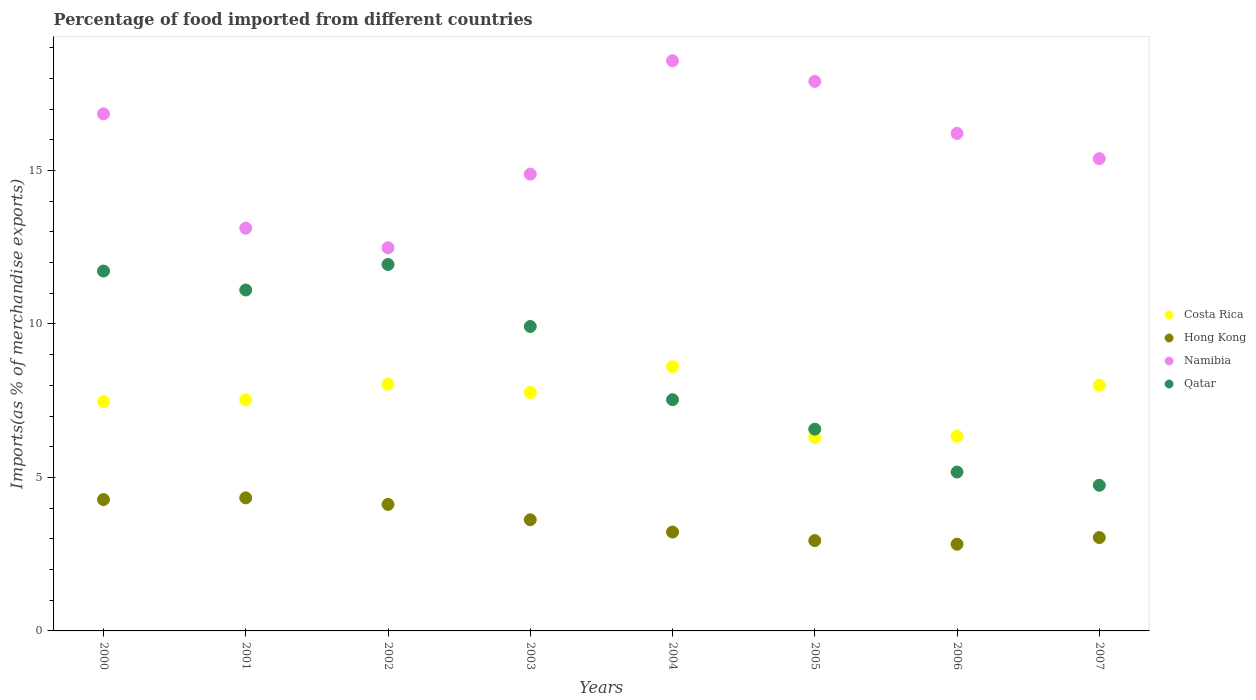How many different coloured dotlines are there?
Your response must be concise. 4. What is the percentage of imports to different countries in Costa Rica in 2004?
Provide a succinct answer. 8.61. Across all years, what is the maximum percentage of imports to different countries in Namibia?
Offer a very short reply. 18.57. Across all years, what is the minimum percentage of imports to different countries in Hong Kong?
Offer a terse response. 2.82. What is the total percentage of imports to different countries in Namibia in the graph?
Make the answer very short. 125.39. What is the difference between the percentage of imports to different countries in Namibia in 2001 and that in 2007?
Provide a short and direct response. -2.26. What is the difference between the percentage of imports to different countries in Hong Kong in 2003 and the percentage of imports to different countries in Qatar in 2005?
Make the answer very short. -2.95. What is the average percentage of imports to different countries in Qatar per year?
Your response must be concise. 8.59. In the year 2000, what is the difference between the percentage of imports to different countries in Hong Kong and percentage of imports to different countries in Costa Rica?
Your response must be concise. -3.19. In how many years, is the percentage of imports to different countries in Costa Rica greater than 12 %?
Offer a terse response. 0. What is the ratio of the percentage of imports to different countries in Namibia in 2005 to that in 2006?
Offer a terse response. 1.1. Is the percentage of imports to different countries in Qatar in 2002 less than that in 2006?
Give a very brief answer. No. What is the difference between the highest and the second highest percentage of imports to different countries in Costa Rica?
Offer a very short reply. 0.57. What is the difference between the highest and the lowest percentage of imports to different countries in Qatar?
Your answer should be very brief. 7.19. In how many years, is the percentage of imports to different countries in Costa Rica greater than the average percentage of imports to different countries in Costa Rica taken over all years?
Give a very brief answer. 5. Is the sum of the percentage of imports to different countries in Costa Rica in 2001 and 2002 greater than the maximum percentage of imports to different countries in Qatar across all years?
Your response must be concise. Yes. Is it the case that in every year, the sum of the percentage of imports to different countries in Qatar and percentage of imports to different countries in Namibia  is greater than the percentage of imports to different countries in Hong Kong?
Offer a terse response. Yes. Does the percentage of imports to different countries in Costa Rica monotonically increase over the years?
Your answer should be very brief. No. Is the percentage of imports to different countries in Costa Rica strictly less than the percentage of imports to different countries in Namibia over the years?
Offer a terse response. Yes. How many dotlines are there?
Provide a succinct answer. 4. How many years are there in the graph?
Keep it short and to the point. 8. What is the difference between two consecutive major ticks on the Y-axis?
Your answer should be very brief. 5. Does the graph contain grids?
Keep it short and to the point. No. Where does the legend appear in the graph?
Your response must be concise. Center right. What is the title of the graph?
Provide a succinct answer. Percentage of food imported from different countries. What is the label or title of the Y-axis?
Your answer should be very brief. Imports(as % of merchandise exports). What is the Imports(as % of merchandise exports) in Costa Rica in 2000?
Your answer should be very brief. 7.47. What is the Imports(as % of merchandise exports) of Hong Kong in 2000?
Give a very brief answer. 4.28. What is the Imports(as % of merchandise exports) in Namibia in 2000?
Keep it short and to the point. 16.84. What is the Imports(as % of merchandise exports) of Qatar in 2000?
Your answer should be compact. 11.72. What is the Imports(as % of merchandise exports) of Costa Rica in 2001?
Offer a very short reply. 7.53. What is the Imports(as % of merchandise exports) in Hong Kong in 2001?
Offer a terse response. 4.33. What is the Imports(as % of merchandise exports) of Namibia in 2001?
Ensure brevity in your answer.  13.12. What is the Imports(as % of merchandise exports) of Qatar in 2001?
Offer a very short reply. 11.11. What is the Imports(as % of merchandise exports) in Costa Rica in 2002?
Your answer should be compact. 8.04. What is the Imports(as % of merchandise exports) in Hong Kong in 2002?
Keep it short and to the point. 4.12. What is the Imports(as % of merchandise exports) of Namibia in 2002?
Keep it short and to the point. 12.48. What is the Imports(as % of merchandise exports) of Qatar in 2002?
Ensure brevity in your answer.  11.94. What is the Imports(as % of merchandise exports) in Costa Rica in 2003?
Your answer should be compact. 7.77. What is the Imports(as % of merchandise exports) of Hong Kong in 2003?
Give a very brief answer. 3.62. What is the Imports(as % of merchandise exports) of Namibia in 2003?
Your response must be concise. 14.88. What is the Imports(as % of merchandise exports) in Qatar in 2003?
Make the answer very short. 9.92. What is the Imports(as % of merchandise exports) of Costa Rica in 2004?
Provide a short and direct response. 8.61. What is the Imports(as % of merchandise exports) in Hong Kong in 2004?
Provide a short and direct response. 3.22. What is the Imports(as % of merchandise exports) in Namibia in 2004?
Provide a succinct answer. 18.57. What is the Imports(as % of merchandise exports) in Qatar in 2004?
Your response must be concise. 7.53. What is the Imports(as % of merchandise exports) in Costa Rica in 2005?
Your response must be concise. 6.3. What is the Imports(as % of merchandise exports) of Hong Kong in 2005?
Provide a succinct answer. 2.94. What is the Imports(as % of merchandise exports) of Namibia in 2005?
Offer a very short reply. 17.9. What is the Imports(as % of merchandise exports) of Qatar in 2005?
Keep it short and to the point. 6.57. What is the Imports(as % of merchandise exports) of Costa Rica in 2006?
Provide a succinct answer. 6.34. What is the Imports(as % of merchandise exports) of Hong Kong in 2006?
Give a very brief answer. 2.82. What is the Imports(as % of merchandise exports) in Namibia in 2006?
Ensure brevity in your answer.  16.21. What is the Imports(as % of merchandise exports) of Qatar in 2006?
Your answer should be compact. 5.18. What is the Imports(as % of merchandise exports) in Costa Rica in 2007?
Your response must be concise. 8.01. What is the Imports(as % of merchandise exports) in Hong Kong in 2007?
Ensure brevity in your answer.  3.04. What is the Imports(as % of merchandise exports) in Namibia in 2007?
Keep it short and to the point. 15.38. What is the Imports(as % of merchandise exports) in Qatar in 2007?
Ensure brevity in your answer.  4.74. Across all years, what is the maximum Imports(as % of merchandise exports) of Costa Rica?
Make the answer very short. 8.61. Across all years, what is the maximum Imports(as % of merchandise exports) in Hong Kong?
Offer a very short reply. 4.33. Across all years, what is the maximum Imports(as % of merchandise exports) of Namibia?
Your answer should be very brief. 18.57. Across all years, what is the maximum Imports(as % of merchandise exports) of Qatar?
Your answer should be compact. 11.94. Across all years, what is the minimum Imports(as % of merchandise exports) in Costa Rica?
Ensure brevity in your answer.  6.3. Across all years, what is the minimum Imports(as % of merchandise exports) in Hong Kong?
Your response must be concise. 2.82. Across all years, what is the minimum Imports(as % of merchandise exports) of Namibia?
Provide a succinct answer. 12.48. Across all years, what is the minimum Imports(as % of merchandise exports) of Qatar?
Provide a succinct answer. 4.74. What is the total Imports(as % of merchandise exports) in Costa Rica in the graph?
Offer a very short reply. 60.05. What is the total Imports(as % of merchandise exports) in Hong Kong in the graph?
Your answer should be very brief. 28.38. What is the total Imports(as % of merchandise exports) of Namibia in the graph?
Provide a succinct answer. 125.39. What is the total Imports(as % of merchandise exports) of Qatar in the graph?
Make the answer very short. 68.71. What is the difference between the Imports(as % of merchandise exports) in Costa Rica in 2000 and that in 2001?
Ensure brevity in your answer.  -0.06. What is the difference between the Imports(as % of merchandise exports) of Hong Kong in 2000 and that in 2001?
Keep it short and to the point. -0.06. What is the difference between the Imports(as % of merchandise exports) of Namibia in 2000 and that in 2001?
Provide a short and direct response. 3.72. What is the difference between the Imports(as % of merchandise exports) of Qatar in 2000 and that in 2001?
Offer a terse response. 0.62. What is the difference between the Imports(as % of merchandise exports) of Costa Rica in 2000 and that in 2002?
Provide a short and direct response. -0.57. What is the difference between the Imports(as % of merchandise exports) in Hong Kong in 2000 and that in 2002?
Your answer should be compact. 0.16. What is the difference between the Imports(as % of merchandise exports) in Namibia in 2000 and that in 2002?
Ensure brevity in your answer.  4.36. What is the difference between the Imports(as % of merchandise exports) of Qatar in 2000 and that in 2002?
Provide a succinct answer. -0.21. What is the difference between the Imports(as % of merchandise exports) of Costa Rica in 2000 and that in 2003?
Make the answer very short. -0.3. What is the difference between the Imports(as % of merchandise exports) of Hong Kong in 2000 and that in 2003?
Your answer should be very brief. 0.66. What is the difference between the Imports(as % of merchandise exports) of Namibia in 2000 and that in 2003?
Ensure brevity in your answer.  1.96. What is the difference between the Imports(as % of merchandise exports) in Qatar in 2000 and that in 2003?
Your answer should be compact. 1.81. What is the difference between the Imports(as % of merchandise exports) of Costa Rica in 2000 and that in 2004?
Give a very brief answer. -1.14. What is the difference between the Imports(as % of merchandise exports) of Hong Kong in 2000 and that in 2004?
Your answer should be very brief. 1.06. What is the difference between the Imports(as % of merchandise exports) of Namibia in 2000 and that in 2004?
Your answer should be very brief. -1.73. What is the difference between the Imports(as % of merchandise exports) of Qatar in 2000 and that in 2004?
Offer a very short reply. 4.19. What is the difference between the Imports(as % of merchandise exports) of Costa Rica in 2000 and that in 2005?
Offer a very short reply. 1.17. What is the difference between the Imports(as % of merchandise exports) in Hong Kong in 2000 and that in 2005?
Ensure brevity in your answer.  1.34. What is the difference between the Imports(as % of merchandise exports) of Namibia in 2000 and that in 2005?
Your answer should be very brief. -1.06. What is the difference between the Imports(as % of merchandise exports) in Qatar in 2000 and that in 2005?
Offer a very short reply. 5.15. What is the difference between the Imports(as % of merchandise exports) of Costa Rica in 2000 and that in 2006?
Your answer should be compact. 1.13. What is the difference between the Imports(as % of merchandise exports) of Hong Kong in 2000 and that in 2006?
Your answer should be very brief. 1.45. What is the difference between the Imports(as % of merchandise exports) in Namibia in 2000 and that in 2006?
Provide a succinct answer. 0.64. What is the difference between the Imports(as % of merchandise exports) of Qatar in 2000 and that in 2006?
Provide a short and direct response. 6.55. What is the difference between the Imports(as % of merchandise exports) of Costa Rica in 2000 and that in 2007?
Keep it short and to the point. -0.54. What is the difference between the Imports(as % of merchandise exports) of Hong Kong in 2000 and that in 2007?
Offer a very short reply. 1.24. What is the difference between the Imports(as % of merchandise exports) of Namibia in 2000 and that in 2007?
Your response must be concise. 1.46. What is the difference between the Imports(as % of merchandise exports) in Qatar in 2000 and that in 2007?
Make the answer very short. 6.98. What is the difference between the Imports(as % of merchandise exports) of Costa Rica in 2001 and that in 2002?
Your answer should be compact. -0.51. What is the difference between the Imports(as % of merchandise exports) of Hong Kong in 2001 and that in 2002?
Keep it short and to the point. 0.21. What is the difference between the Imports(as % of merchandise exports) in Namibia in 2001 and that in 2002?
Your answer should be very brief. 0.64. What is the difference between the Imports(as % of merchandise exports) in Qatar in 2001 and that in 2002?
Offer a very short reply. -0.83. What is the difference between the Imports(as % of merchandise exports) in Costa Rica in 2001 and that in 2003?
Your answer should be very brief. -0.24. What is the difference between the Imports(as % of merchandise exports) of Hong Kong in 2001 and that in 2003?
Offer a terse response. 0.71. What is the difference between the Imports(as % of merchandise exports) in Namibia in 2001 and that in 2003?
Your answer should be very brief. -1.76. What is the difference between the Imports(as % of merchandise exports) of Qatar in 2001 and that in 2003?
Your answer should be very brief. 1.19. What is the difference between the Imports(as % of merchandise exports) of Costa Rica in 2001 and that in 2004?
Ensure brevity in your answer.  -1.08. What is the difference between the Imports(as % of merchandise exports) of Hong Kong in 2001 and that in 2004?
Give a very brief answer. 1.11. What is the difference between the Imports(as % of merchandise exports) in Namibia in 2001 and that in 2004?
Your answer should be compact. -5.45. What is the difference between the Imports(as % of merchandise exports) in Qatar in 2001 and that in 2004?
Your response must be concise. 3.57. What is the difference between the Imports(as % of merchandise exports) of Costa Rica in 2001 and that in 2005?
Offer a terse response. 1.22. What is the difference between the Imports(as % of merchandise exports) in Hong Kong in 2001 and that in 2005?
Give a very brief answer. 1.39. What is the difference between the Imports(as % of merchandise exports) of Namibia in 2001 and that in 2005?
Your answer should be very brief. -4.78. What is the difference between the Imports(as % of merchandise exports) of Qatar in 2001 and that in 2005?
Your response must be concise. 4.53. What is the difference between the Imports(as % of merchandise exports) in Costa Rica in 2001 and that in 2006?
Make the answer very short. 1.18. What is the difference between the Imports(as % of merchandise exports) of Hong Kong in 2001 and that in 2006?
Provide a succinct answer. 1.51. What is the difference between the Imports(as % of merchandise exports) in Namibia in 2001 and that in 2006?
Your answer should be very brief. -3.09. What is the difference between the Imports(as % of merchandise exports) in Qatar in 2001 and that in 2006?
Offer a terse response. 5.93. What is the difference between the Imports(as % of merchandise exports) of Costa Rica in 2001 and that in 2007?
Provide a succinct answer. -0.48. What is the difference between the Imports(as % of merchandise exports) of Hong Kong in 2001 and that in 2007?
Offer a terse response. 1.29. What is the difference between the Imports(as % of merchandise exports) of Namibia in 2001 and that in 2007?
Your answer should be very brief. -2.26. What is the difference between the Imports(as % of merchandise exports) of Qatar in 2001 and that in 2007?
Offer a very short reply. 6.36. What is the difference between the Imports(as % of merchandise exports) in Costa Rica in 2002 and that in 2003?
Your answer should be compact. 0.27. What is the difference between the Imports(as % of merchandise exports) in Hong Kong in 2002 and that in 2003?
Your answer should be compact. 0.5. What is the difference between the Imports(as % of merchandise exports) of Namibia in 2002 and that in 2003?
Keep it short and to the point. -2.4. What is the difference between the Imports(as % of merchandise exports) of Qatar in 2002 and that in 2003?
Ensure brevity in your answer.  2.02. What is the difference between the Imports(as % of merchandise exports) in Costa Rica in 2002 and that in 2004?
Make the answer very short. -0.57. What is the difference between the Imports(as % of merchandise exports) of Hong Kong in 2002 and that in 2004?
Your answer should be very brief. 0.9. What is the difference between the Imports(as % of merchandise exports) in Namibia in 2002 and that in 2004?
Give a very brief answer. -6.09. What is the difference between the Imports(as % of merchandise exports) of Qatar in 2002 and that in 2004?
Make the answer very short. 4.4. What is the difference between the Imports(as % of merchandise exports) of Costa Rica in 2002 and that in 2005?
Offer a very short reply. 1.74. What is the difference between the Imports(as % of merchandise exports) of Hong Kong in 2002 and that in 2005?
Your answer should be compact. 1.18. What is the difference between the Imports(as % of merchandise exports) in Namibia in 2002 and that in 2005?
Keep it short and to the point. -5.42. What is the difference between the Imports(as % of merchandise exports) in Qatar in 2002 and that in 2005?
Make the answer very short. 5.36. What is the difference between the Imports(as % of merchandise exports) in Costa Rica in 2002 and that in 2006?
Offer a terse response. 1.7. What is the difference between the Imports(as % of merchandise exports) of Hong Kong in 2002 and that in 2006?
Make the answer very short. 1.3. What is the difference between the Imports(as % of merchandise exports) in Namibia in 2002 and that in 2006?
Offer a terse response. -3.72. What is the difference between the Imports(as % of merchandise exports) of Qatar in 2002 and that in 2006?
Give a very brief answer. 6.76. What is the difference between the Imports(as % of merchandise exports) of Costa Rica in 2002 and that in 2007?
Your answer should be compact. 0.03. What is the difference between the Imports(as % of merchandise exports) in Hong Kong in 2002 and that in 2007?
Provide a succinct answer. 1.08. What is the difference between the Imports(as % of merchandise exports) of Namibia in 2002 and that in 2007?
Make the answer very short. -2.9. What is the difference between the Imports(as % of merchandise exports) in Qatar in 2002 and that in 2007?
Offer a very short reply. 7.19. What is the difference between the Imports(as % of merchandise exports) in Costa Rica in 2003 and that in 2004?
Provide a short and direct response. -0.84. What is the difference between the Imports(as % of merchandise exports) of Hong Kong in 2003 and that in 2004?
Provide a short and direct response. 0.4. What is the difference between the Imports(as % of merchandise exports) in Namibia in 2003 and that in 2004?
Make the answer very short. -3.69. What is the difference between the Imports(as % of merchandise exports) of Qatar in 2003 and that in 2004?
Make the answer very short. 2.39. What is the difference between the Imports(as % of merchandise exports) of Costa Rica in 2003 and that in 2005?
Give a very brief answer. 1.46. What is the difference between the Imports(as % of merchandise exports) of Hong Kong in 2003 and that in 2005?
Offer a very short reply. 0.68. What is the difference between the Imports(as % of merchandise exports) of Namibia in 2003 and that in 2005?
Provide a succinct answer. -3.02. What is the difference between the Imports(as % of merchandise exports) of Qatar in 2003 and that in 2005?
Your response must be concise. 3.34. What is the difference between the Imports(as % of merchandise exports) in Costa Rica in 2003 and that in 2006?
Your response must be concise. 1.42. What is the difference between the Imports(as % of merchandise exports) in Hong Kong in 2003 and that in 2006?
Your answer should be compact. 0.8. What is the difference between the Imports(as % of merchandise exports) of Namibia in 2003 and that in 2006?
Make the answer very short. -1.33. What is the difference between the Imports(as % of merchandise exports) in Qatar in 2003 and that in 2006?
Provide a short and direct response. 4.74. What is the difference between the Imports(as % of merchandise exports) of Costa Rica in 2003 and that in 2007?
Ensure brevity in your answer.  -0.24. What is the difference between the Imports(as % of merchandise exports) of Hong Kong in 2003 and that in 2007?
Provide a succinct answer. 0.58. What is the difference between the Imports(as % of merchandise exports) of Namibia in 2003 and that in 2007?
Your response must be concise. -0.5. What is the difference between the Imports(as % of merchandise exports) of Qatar in 2003 and that in 2007?
Give a very brief answer. 5.17. What is the difference between the Imports(as % of merchandise exports) in Costa Rica in 2004 and that in 2005?
Your answer should be very brief. 2.31. What is the difference between the Imports(as % of merchandise exports) of Hong Kong in 2004 and that in 2005?
Ensure brevity in your answer.  0.28. What is the difference between the Imports(as % of merchandise exports) in Namibia in 2004 and that in 2005?
Provide a succinct answer. 0.67. What is the difference between the Imports(as % of merchandise exports) in Qatar in 2004 and that in 2005?
Offer a very short reply. 0.96. What is the difference between the Imports(as % of merchandise exports) in Costa Rica in 2004 and that in 2006?
Provide a short and direct response. 2.27. What is the difference between the Imports(as % of merchandise exports) of Hong Kong in 2004 and that in 2006?
Make the answer very short. 0.4. What is the difference between the Imports(as % of merchandise exports) in Namibia in 2004 and that in 2006?
Your response must be concise. 2.37. What is the difference between the Imports(as % of merchandise exports) of Qatar in 2004 and that in 2006?
Your response must be concise. 2.36. What is the difference between the Imports(as % of merchandise exports) in Costa Rica in 2004 and that in 2007?
Your answer should be compact. 0.6. What is the difference between the Imports(as % of merchandise exports) of Hong Kong in 2004 and that in 2007?
Give a very brief answer. 0.18. What is the difference between the Imports(as % of merchandise exports) of Namibia in 2004 and that in 2007?
Give a very brief answer. 3.19. What is the difference between the Imports(as % of merchandise exports) of Qatar in 2004 and that in 2007?
Your answer should be very brief. 2.79. What is the difference between the Imports(as % of merchandise exports) in Costa Rica in 2005 and that in 2006?
Your answer should be very brief. -0.04. What is the difference between the Imports(as % of merchandise exports) in Hong Kong in 2005 and that in 2006?
Ensure brevity in your answer.  0.12. What is the difference between the Imports(as % of merchandise exports) in Namibia in 2005 and that in 2006?
Offer a terse response. 1.69. What is the difference between the Imports(as % of merchandise exports) in Qatar in 2005 and that in 2006?
Give a very brief answer. 1.4. What is the difference between the Imports(as % of merchandise exports) of Costa Rica in 2005 and that in 2007?
Offer a terse response. -1.71. What is the difference between the Imports(as % of merchandise exports) in Hong Kong in 2005 and that in 2007?
Provide a succinct answer. -0.1. What is the difference between the Imports(as % of merchandise exports) in Namibia in 2005 and that in 2007?
Offer a very short reply. 2.52. What is the difference between the Imports(as % of merchandise exports) in Qatar in 2005 and that in 2007?
Offer a very short reply. 1.83. What is the difference between the Imports(as % of merchandise exports) in Costa Rica in 2006 and that in 2007?
Your answer should be very brief. -1.67. What is the difference between the Imports(as % of merchandise exports) of Hong Kong in 2006 and that in 2007?
Keep it short and to the point. -0.22. What is the difference between the Imports(as % of merchandise exports) of Namibia in 2006 and that in 2007?
Give a very brief answer. 0.82. What is the difference between the Imports(as % of merchandise exports) in Qatar in 2006 and that in 2007?
Keep it short and to the point. 0.43. What is the difference between the Imports(as % of merchandise exports) of Costa Rica in 2000 and the Imports(as % of merchandise exports) of Hong Kong in 2001?
Your answer should be compact. 3.13. What is the difference between the Imports(as % of merchandise exports) in Costa Rica in 2000 and the Imports(as % of merchandise exports) in Namibia in 2001?
Offer a very short reply. -5.65. What is the difference between the Imports(as % of merchandise exports) of Costa Rica in 2000 and the Imports(as % of merchandise exports) of Qatar in 2001?
Offer a terse response. -3.64. What is the difference between the Imports(as % of merchandise exports) of Hong Kong in 2000 and the Imports(as % of merchandise exports) of Namibia in 2001?
Provide a succinct answer. -8.84. What is the difference between the Imports(as % of merchandise exports) in Hong Kong in 2000 and the Imports(as % of merchandise exports) in Qatar in 2001?
Make the answer very short. -6.83. What is the difference between the Imports(as % of merchandise exports) of Namibia in 2000 and the Imports(as % of merchandise exports) of Qatar in 2001?
Keep it short and to the point. 5.74. What is the difference between the Imports(as % of merchandise exports) of Costa Rica in 2000 and the Imports(as % of merchandise exports) of Hong Kong in 2002?
Make the answer very short. 3.35. What is the difference between the Imports(as % of merchandise exports) in Costa Rica in 2000 and the Imports(as % of merchandise exports) in Namibia in 2002?
Provide a succinct answer. -5.01. What is the difference between the Imports(as % of merchandise exports) of Costa Rica in 2000 and the Imports(as % of merchandise exports) of Qatar in 2002?
Your answer should be compact. -4.47. What is the difference between the Imports(as % of merchandise exports) of Hong Kong in 2000 and the Imports(as % of merchandise exports) of Namibia in 2002?
Offer a very short reply. -8.2. What is the difference between the Imports(as % of merchandise exports) in Hong Kong in 2000 and the Imports(as % of merchandise exports) in Qatar in 2002?
Make the answer very short. -7.66. What is the difference between the Imports(as % of merchandise exports) of Namibia in 2000 and the Imports(as % of merchandise exports) of Qatar in 2002?
Ensure brevity in your answer.  4.91. What is the difference between the Imports(as % of merchandise exports) of Costa Rica in 2000 and the Imports(as % of merchandise exports) of Hong Kong in 2003?
Provide a succinct answer. 3.85. What is the difference between the Imports(as % of merchandise exports) in Costa Rica in 2000 and the Imports(as % of merchandise exports) in Namibia in 2003?
Give a very brief answer. -7.41. What is the difference between the Imports(as % of merchandise exports) in Costa Rica in 2000 and the Imports(as % of merchandise exports) in Qatar in 2003?
Your response must be concise. -2.45. What is the difference between the Imports(as % of merchandise exports) in Hong Kong in 2000 and the Imports(as % of merchandise exports) in Namibia in 2003?
Your answer should be very brief. -10.6. What is the difference between the Imports(as % of merchandise exports) of Hong Kong in 2000 and the Imports(as % of merchandise exports) of Qatar in 2003?
Provide a short and direct response. -5.64. What is the difference between the Imports(as % of merchandise exports) of Namibia in 2000 and the Imports(as % of merchandise exports) of Qatar in 2003?
Offer a very short reply. 6.93. What is the difference between the Imports(as % of merchandise exports) in Costa Rica in 2000 and the Imports(as % of merchandise exports) in Hong Kong in 2004?
Offer a terse response. 4.25. What is the difference between the Imports(as % of merchandise exports) of Costa Rica in 2000 and the Imports(as % of merchandise exports) of Namibia in 2004?
Give a very brief answer. -11.11. What is the difference between the Imports(as % of merchandise exports) in Costa Rica in 2000 and the Imports(as % of merchandise exports) in Qatar in 2004?
Your answer should be compact. -0.06. What is the difference between the Imports(as % of merchandise exports) of Hong Kong in 2000 and the Imports(as % of merchandise exports) of Namibia in 2004?
Offer a very short reply. -14.29. What is the difference between the Imports(as % of merchandise exports) in Hong Kong in 2000 and the Imports(as % of merchandise exports) in Qatar in 2004?
Offer a very short reply. -3.25. What is the difference between the Imports(as % of merchandise exports) in Namibia in 2000 and the Imports(as % of merchandise exports) in Qatar in 2004?
Your answer should be compact. 9.31. What is the difference between the Imports(as % of merchandise exports) of Costa Rica in 2000 and the Imports(as % of merchandise exports) of Hong Kong in 2005?
Offer a very short reply. 4.53. What is the difference between the Imports(as % of merchandise exports) of Costa Rica in 2000 and the Imports(as % of merchandise exports) of Namibia in 2005?
Offer a very short reply. -10.43. What is the difference between the Imports(as % of merchandise exports) of Costa Rica in 2000 and the Imports(as % of merchandise exports) of Qatar in 2005?
Your answer should be compact. 0.9. What is the difference between the Imports(as % of merchandise exports) of Hong Kong in 2000 and the Imports(as % of merchandise exports) of Namibia in 2005?
Give a very brief answer. -13.62. What is the difference between the Imports(as % of merchandise exports) of Hong Kong in 2000 and the Imports(as % of merchandise exports) of Qatar in 2005?
Give a very brief answer. -2.29. What is the difference between the Imports(as % of merchandise exports) in Namibia in 2000 and the Imports(as % of merchandise exports) in Qatar in 2005?
Provide a short and direct response. 10.27. What is the difference between the Imports(as % of merchandise exports) in Costa Rica in 2000 and the Imports(as % of merchandise exports) in Hong Kong in 2006?
Provide a short and direct response. 4.64. What is the difference between the Imports(as % of merchandise exports) in Costa Rica in 2000 and the Imports(as % of merchandise exports) in Namibia in 2006?
Provide a succinct answer. -8.74. What is the difference between the Imports(as % of merchandise exports) of Costa Rica in 2000 and the Imports(as % of merchandise exports) of Qatar in 2006?
Keep it short and to the point. 2.29. What is the difference between the Imports(as % of merchandise exports) in Hong Kong in 2000 and the Imports(as % of merchandise exports) in Namibia in 2006?
Provide a succinct answer. -11.93. What is the difference between the Imports(as % of merchandise exports) in Hong Kong in 2000 and the Imports(as % of merchandise exports) in Qatar in 2006?
Offer a terse response. -0.9. What is the difference between the Imports(as % of merchandise exports) in Namibia in 2000 and the Imports(as % of merchandise exports) in Qatar in 2006?
Your answer should be compact. 11.67. What is the difference between the Imports(as % of merchandise exports) in Costa Rica in 2000 and the Imports(as % of merchandise exports) in Hong Kong in 2007?
Offer a terse response. 4.43. What is the difference between the Imports(as % of merchandise exports) of Costa Rica in 2000 and the Imports(as % of merchandise exports) of Namibia in 2007?
Offer a very short reply. -7.91. What is the difference between the Imports(as % of merchandise exports) in Costa Rica in 2000 and the Imports(as % of merchandise exports) in Qatar in 2007?
Keep it short and to the point. 2.72. What is the difference between the Imports(as % of merchandise exports) in Hong Kong in 2000 and the Imports(as % of merchandise exports) in Namibia in 2007?
Provide a short and direct response. -11.1. What is the difference between the Imports(as % of merchandise exports) of Hong Kong in 2000 and the Imports(as % of merchandise exports) of Qatar in 2007?
Keep it short and to the point. -0.47. What is the difference between the Imports(as % of merchandise exports) in Namibia in 2000 and the Imports(as % of merchandise exports) in Qatar in 2007?
Give a very brief answer. 12.1. What is the difference between the Imports(as % of merchandise exports) of Costa Rica in 2001 and the Imports(as % of merchandise exports) of Hong Kong in 2002?
Give a very brief answer. 3.4. What is the difference between the Imports(as % of merchandise exports) in Costa Rica in 2001 and the Imports(as % of merchandise exports) in Namibia in 2002?
Provide a short and direct response. -4.96. What is the difference between the Imports(as % of merchandise exports) in Costa Rica in 2001 and the Imports(as % of merchandise exports) in Qatar in 2002?
Your response must be concise. -4.41. What is the difference between the Imports(as % of merchandise exports) in Hong Kong in 2001 and the Imports(as % of merchandise exports) in Namibia in 2002?
Your answer should be very brief. -8.15. What is the difference between the Imports(as % of merchandise exports) in Hong Kong in 2001 and the Imports(as % of merchandise exports) in Qatar in 2002?
Ensure brevity in your answer.  -7.6. What is the difference between the Imports(as % of merchandise exports) in Namibia in 2001 and the Imports(as % of merchandise exports) in Qatar in 2002?
Offer a very short reply. 1.18. What is the difference between the Imports(as % of merchandise exports) in Costa Rica in 2001 and the Imports(as % of merchandise exports) in Hong Kong in 2003?
Provide a succinct answer. 3.9. What is the difference between the Imports(as % of merchandise exports) in Costa Rica in 2001 and the Imports(as % of merchandise exports) in Namibia in 2003?
Make the answer very short. -7.36. What is the difference between the Imports(as % of merchandise exports) in Costa Rica in 2001 and the Imports(as % of merchandise exports) in Qatar in 2003?
Provide a succinct answer. -2.39. What is the difference between the Imports(as % of merchandise exports) of Hong Kong in 2001 and the Imports(as % of merchandise exports) of Namibia in 2003?
Your answer should be very brief. -10.55. What is the difference between the Imports(as % of merchandise exports) in Hong Kong in 2001 and the Imports(as % of merchandise exports) in Qatar in 2003?
Your answer should be compact. -5.58. What is the difference between the Imports(as % of merchandise exports) of Namibia in 2001 and the Imports(as % of merchandise exports) of Qatar in 2003?
Your answer should be very brief. 3.2. What is the difference between the Imports(as % of merchandise exports) in Costa Rica in 2001 and the Imports(as % of merchandise exports) in Hong Kong in 2004?
Give a very brief answer. 4.3. What is the difference between the Imports(as % of merchandise exports) of Costa Rica in 2001 and the Imports(as % of merchandise exports) of Namibia in 2004?
Make the answer very short. -11.05. What is the difference between the Imports(as % of merchandise exports) of Costa Rica in 2001 and the Imports(as % of merchandise exports) of Qatar in 2004?
Ensure brevity in your answer.  -0.01. What is the difference between the Imports(as % of merchandise exports) of Hong Kong in 2001 and the Imports(as % of merchandise exports) of Namibia in 2004?
Keep it short and to the point. -14.24. What is the difference between the Imports(as % of merchandise exports) in Hong Kong in 2001 and the Imports(as % of merchandise exports) in Qatar in 2004?
Keep it short and to the point. -3.2. What is the difference between the Imports(as % of merchandise exports) of Namibia in 2001 and the Imports(as % of merchandise exports) of Qatar in 2004?
Make the answer very short. 5.59. What is the difference between the Imports(as % of merchandise exports) of Costa Rica in 2001 and the Imports(as % of merchandise exports) of Hong Kong in 2005?
Ensure brevity in your answer.  4.58. What is the difference between the Imports(as % of merchandise exports) of Costa Rica in 2001 and the Imports(as % of merchandise exports) of Namibia in 2005?
Offer a terse response. -10.38. What is the difference between the Imports(as % of merchandise exports) in Costa Rica in 2001 and the Imports(as % of merchandise exports) in Qatar in 2005?
Offer a terse response. 0.95. What is the difference between the Imports(as % of merchandise exports) in Hong Kong in 2001 and the Imports(as % of merchandise exports) in Namibia in 2005?
Offer a very short reply. -13.57. What is the difference between the Imports(as % of merchandise exports) of Hong Kong in 2001 and the Imports(as % of merchandise exports) of Qatar in 2005?
Provide a succinct answer. -2.24. What is the difference between the Imports(as % of merchandise exports) in Namibia in 2001 and the Imports(as % of merchandise exports) in Qatar in 2005?
Offer a terse response. 6.55. What is the difference between the Imports(as % of merchandise exports) of Costa Rica in 2001 and the Imports(as % of merchandise exports) of Hong Kong in 2006?
Offer a terse response. 4.7. What is the difference between the Imports(as % of merchandise exports) of Costa Rica in 2001 and the Imports(as % of merchandise exports) of Namibia in 2006?
Your answer should be very brief. -8.68. What is the difference between the Imports(as % of merchandise exports) of Costa Rica in 2001 and the Imports(as % of merchandise exports) of Qatar in 2006?
Your answer should be compact. 2.35. What is the difference between the Imports(as % of merchandise exports) in Hong Kong in 2001 and the Imports(as % of merchandise exports) in Namibia in 2006?
Provide a short and direct response. -11.87. What is the difference between the Imports(as % of merchandise exports) in Hong Kong in 2001 and the Imports(as % of merchandise exports) in Qatar in 2006?
Give a very brief answer. -0.84. What is the difference between the Imports(as % of merchandise exports) of Namibia in 2001 and the Imports(as % of merchandise exports) of Qatar in 2006?
Give a very brief answer. 7.94. What is the difference between the Imports(as % of merchandise exports) of Costa Rica in 2001 and the Imports(as % of merchandise exports) of Hong Kong in 2007?
Ensure brevity in your answer.  4.48. What is the difference between the Imports(as % of merchandise exports) of Costa Rica in 2001 and the Imports(as % of merchandise exports) of Namibia in 2007?
Make the answer very short. -7.86. What is the difference between the Imports(as % of merchandise exports) in Costa Rica in 2001 and the Imports(as % of merchandise exports) in Qatar in 2007?
Your answer should be very brief. 2.78. What is the difference between the Imports(as % of merchandise exports) of Hong Kong in 2001 and the Imports(as % of merchandise exports) of Namibia in 2007?
Provide a succinct answer. -11.05. What is the difference between the Imports(as % of merchandise exports) in Hong Kong in 2001 and the Imports(as % of merchandise exports) in Qatar in 2007?
Make the answer very short. -0.41. What is the difference between the Imports(as % of merchandise exports) of Namibia in 2001 and the Imports(as % of merchandise exports) of Qatar in 2007?
Make the answer very short. 8.38. What is the difference between the Imports(as % of merchandise exports) of Costa Rica in 2002 and the Imports(as % of merchandise exports) of Hong Kong in 2003?
Ensure brevity in your answer.  4.42. What is the difference between the Imports(as % of merchandise exports) in Costa Rica in 2002 and the Imports(as % of merchandise exports) in Namibia in 2003?
Ensure brevity in your answer.  -6.84. What is the difference between the Imports(as % of merchandise exports) in Costa Rica in 2002 and the Imports(as % of merchandise exports) in Qatar in 2003?
Offer a very short reply. -1.88. What is the difference between the Imports(as % of merchandise exports) of Hong Kong in 2002 and the Imports(as % of merchandise exports) of Namibia in 2003?
Offer a terse response. -10.76. What is the difference between the Imports(as % of merchandise exports) in Hong Kong in 2002 and the Imports(as % of merchandise exports) in Qatar in 2003?
Keep it short and to the point. -5.8. What is the difference between the Imports(as % of merchandise exports) of Namibia in 2002 and the Imports(as % of merchandise exports) of Qatar in 2003?
Provide a short and direct response. 2.56. What is the difference between the Imports(as % of merchandise exports) of Costa Rica in 2002 and the Imports(as % of merchandise exports) of Hong Kong in 2004?
Keep it short and to the point. 4.82. What is the difference between the Imports(as % of merchandise exports) of Costa Rica in 2002 and the Imports(as % of merchandise exports) of Namibia in 2004?
Make the answer very short. -10.53. What is the difference between the Imports(as % of merchandise exports) in Costa Rica in 2002 and the Imports(as % of merchandise exports) in Qatar in 2004?
Make the answer very short. 0.51. What is the difference between the Imports(as % of merchandise exports) in Hong Kong in 2002 and the Imports(as % of merchandise exports) in Namibia in 2004?
Your answer should be compact. -14.45. What is the difference between the Imports(as % of merchandise exports) in Hong Kong in 2002 and the Imports(as % of merchandise exports) in Qatar in 2004?
Make the answer very short. -3.41. What is the difference between the Imports(as % of merchandise exports) of Namibia in 2002 and the Imports(as % of merchandise exports) of Qatar in 2004?
Keep it short and to the point. 4.95. What is the difference between the Imports(as % of merchandise exports) of Costa Rica in 2002 and the Imports(as % of merchandise exports) of Hong Kong in 2005?
Offer a very short reply. 5.1. What is the difference between the Imports(as % of merchandise exports) in Costa Rica in 2002 and the Imports(as % of merchandise exports) in Namibia in 2005?
Keep it short and to the point. -9.86. What is the difference between the Imports(as % of merchandise exports) in Costa Rica in 2002 and the Imports(as % of merchandise exports) in Qatar in 2005?
Your answer should be very brief. 1.47. What is the difference between the Imports(as % of merchandise exports) in Hong Kong in 2002 and the Imports(as % of merchandise exports) in Namibia in 2005?
Keep it short and to the point. -13.78. What is the difference between the Imports(as % of merchandise exports) of Hong Kong in 2002 and the Imports(as % of merchandise exports) of Qatar in 2005?
Offer a very short reply. -2.45. What is the difference between the Imports(as % of merchandise exports) of Namibia in 2002 and the Imports(as % of merchandise exports) of Qatar in 2005?
Keep it short and to the point. 5.91. What is the difference between the Imports(as % of merchandise exports) in Costa Rica in 2002 and the Imports(as % of merchandise exports) in Hong Kong in 2006?
Your response must be concise. 5.21. What is the difference between the Imports(as % of merchandise exports) in Costa Rica in 2002 and the Imports(as % of merchandise exports) in Namibia in 2006?
Provide a succinct answer. -8.17. What is the difference between the Imports(as % of merchandise exports) of Costa Rica in 2002 and the Imports(as % of merchandise exports) of Qatar in 2006?
Make the answer very short. 2.86. What is the difference between the Imports(as % of merchandise exports) of Hong Kong in 2002 and the Imports(as % of merchandise exports) of Namibia in 2006?
Offer a very short reply. -12.09. What is the difference between the Imports(as % of merchandise exports) of Hong Kong in 2002 and the Imports(as % of merchandise exports) of Qatar in 2006?
Make the answer very short. -1.05. What is the difference between the Imports(as % of merchandise exports) of Namibia in 2002 and the Imports(as % of merchandise exports) of Qatar in 2006?
Make the answer very short. 7.31. What is the difference between the Imports(as % of merchandise exports) in Costa Rica in 2002 and the Imports(as % of merchandise exports) in Hong Kong in 2007?
Ensure brevity in your answer.  5. What is the difference between the Imports(as % of merchandise exports) in Costa Rica in 2002 and the Imports(as % of merchandise exports) in Namibia in 2007?
Your answer should be very brief. -7.34. What is the difference between the Imports(as % of merchandise exports) of Costa Rica in 2002 and the Imports(as % of merchandise exports) of Qatar in 2007?
Offer a terse response. 3.3. What is the difference between the Imports(as % of merchandise exports) in Hong Kong in 2002 and the Imports(as % of merchandise exports) in Namibia in 2007?
Provide a short and direct response. -11.26. What is the difference between the Imports(as % of merchandise exports) in Hong Kong in 2002 and the Imports(as % of merchandise exports) in Qatar in 2007?
Keep it short and to the point. -0.62. What is the difference between the Imports(as % of merchandise exports) of Namibia in 2002 and the Imports(as % of merchandise exports) of Qatar in 2007?
Provide a succinct answer. 7.74. What is the difference between the Imports(as % of merchandise exports) in Costa Rica in 2003 and the Imports(as % of merchandise exports) in Hong Kong in 2004?
Your answer should be very brief. 4.54. What is the difference between the Imports(as % of merchandise exports) in Costa Rica in 2003 and the Imports(as % of merchandise exports) in Namibia in 2004?
Provide a succinct answer. -10.81. What is the difference between the Imports(as % of merchandise exports) in Costa Rica in 2003 and the Imports(as % of merchandise exports) in Qatar in 2004?
Make the answer very short. 0.23. What is the difference between the Imports(as % of merchandise exports) of Hong Kong in 2003 and the Imports(as % of merchandise exports) of Namibia in 2004?
Make the answer very short. -14.95. What is the difference between the Imports(as % of merchandise exports) in Hong Kong in 2003 and the Imports(as % of merchandise exports) in Qatar in 2004?
Keep it short and to the point. -3.91. What is the difference between the Imports(as % of merchandise exports) in Namibia in 2003 and the Imports(as % of merchandise exports) in Qatar in 2004?
Your response must be concise. 7.35. What is the difference between the Imports(as % of merchandise exports) of Costa Rica in 2003 and the Imports(as % of merchandise exports) of Hong Kong in 2005?
Ensure brevity in your answer.  4.82. What is the difference between the Imports(as % of merchandise exports) of Costa Rica in 2003 and the Imports(as % of merchandise exports) of Namibia in 2005?
Make the answer very short. -10.14. What is the difference between the Imports(as % of merchandise exports) of Costa Rica in 2003 and the Imports(as % of merchandise exports) of Qatar in 2005?
Keep it short and to the point. 1.19. What is the difference between the Imports(as % of merchandise exports) in Hong Kong in 2003 and the Imports(as % of merchandise exports) in Namibia in 2005?
Ensure brevity in your answer.  -14.28. What is the difference between the Imports(as % of merchandise exports) of Hong Kong in 2003 and the Imports(as % of merchandise exports) of Qatar in 2005?
Your answer should be very brief. -2.95. What is the difference between the Imports(as % of merchandise exports) in Namibia in 2003 and the Imports(as % of merchandise exports) in Qatar in 2005?
Provide a short and direct response. 8.31. What is the difference between the Imports(as % of merchandise exports) in Costa Rica in 2003 and the Imports(as % of merchandise exports) in Hong Kong in 2006?
Offer a terse response. 4.94. What is the difference between the Imports(as % of merchandise exports) in Costa Rica in 2003 and the Imports(as % of merchandise exports) in Namibia in 2006?
Provide a short and direct response. -8.44. What is the difference between the Imports(as % of merchandise exports) in Costa Rica in 2003 and the Imports(as % of merchandise exports) in Qatar in 2006?
Offer a terse response. 2.59. What is the difference between the Imports(as % of merchandise exports) in Hong Kong in 2003 and the Imports(as % of merchandise exports) in Namibia in 2006?
Offer a very short reply. -12.59. What is the difference between the Imports(as % of merchandise exports) of Hong Kong in 2003 and the Imports(as % of merchandise exports) of Qatar in 2006?
Offer a very short reply. -1.55. What is the difference between the Imports(as % of merchandise exports) in Namibia in 2003 and the Imports(as % of merchandise exports) in Qatar in 2006?
Offer a terse response. 9.71. What is the difference between the Imports(as % of merchandise exports) of Costa Rica in 2003 and the Imports(as % of merchandise exports) of Hong Kong in 2007?
Your response must be concise. 4.72. What is the difference between the Imports(as % of merchandise exports) in Costa Rica in 2003 and the Imports(as % of merchandise exports) in Namibia in 2007?
Give a very brief answer. -7.62. What is the difference between the Imports(as % of merchandise exports) in Costa Rica in 2003 and the Imports(as % of merchandise exports) in Qatar in 2007?
Provide a succinct answer. 3.02. What is the difference between the Imports(as % of merchandise exports) in Hong Kong in 2003 and the Imports(as % of merchandise exports) in Namibia in 2007?
Offer a very short reply. -11.76. What is the difference between the Imports(as % of merchandise exports) of Hong Kong in 2003 and the Imports(as % of merchandise exports) of Qatar in 2007?
Make the answer very short. -1.12. What is the difference between the Imports(as % of merchandise exports) in Namibia in 2003 and the Imports(as % of merchandise exports) in Qatar in 2007?
Offer a very short reply. 10.14. What is the difference between the Imports(as % of merchandise exports) of Costa Rica in 2004 and the Imports(as % of merchandise exports) of Hong Kong in 2005?
Offer a terse response. 5.66. What is the difference between the Imports(as % of merchandise exports) of Costa Rica in 2004 and the Imports(as % of merchandise exports) of Namibia in 2005?
Offer a very short reply. -9.29. What is the difference between the Imports(as % of merchandise exports) of Costa Rica in 2004 and the Imports(as % of merchandise exports) of Qatar in 2005?
Your answer should be compact. 2.03. What is the difference between the Imports(as % of merchandise exports) in Hong Kong in 2004 and the Imports(as % of merchandise exports) in Namibia in 2005?
Provide a succinct answer. -14.68. What is the difference between the Imports(as % of merchandise exports) of Hong Kong in 2004 and the Imports(as % of merchandise exports) of Qatar in 2005?
Keep it short and to the point. -3.35. What is the difference between the Imports(as % of merchandise exports) of Namibia in 2004 and the Imports(as % of merchandise exports) of Qatar in 2005?
Give a very brief answer. 12. What is the difference between the Imports(as % of merchandise exports) in Costa Rica in 2004 and the Imports(as % of merchandise exports) in Hong Kong in 2006?
Offer a terse response. 5.78. What is the difference between the Imports(as % of merchandise exports) in Costa Rica in 2004 and the Imports(as % of merchandise exports) in Namibia in 2006?
Offer a very short reply. -7.6. What is the difference between the Imports(as % of merchandise exports) of Costa Rica in 2004 and the Imports(as % of merchandise exports) of Qatar in 2006?
Offer a terse response. 3.43. What is the difference between the Imports(as % of merchandise exports) of Hong Kong in 2004 and the Imports(as % of merchandise exports) of Namibia in 2006?
Make the answer very short. -12.98. What is the difference between the Imports(as % of merchandise exports) in Hong Kong in 2004 and the Imports(as % of merchandise exports) in Qatar in 2006?
Give a very brief answer. -1.95. What is the difference between the Imports(as % of merchandise exports) in Namibia in 2004 and the Imports(as % of merchandise exports) in Qatar in 2006?
Offer a terse response. 13.4. What is the difference between the Imports(as % of merchandise exports) of Costa Rica in 2004 and the Imports(as % of merchandise exports) of Hong Kong in 2007?
Keep it short and to the point. 5.57. What is the difference between the Imports(as % of merchandise exports) in Costa Rica in 2004 and the Imports(as % of merchandise exports) in Namibia in 2007?
Offer a very short reply. -6.78. What is the difference between the Imports(as % of merchandise exports) in Costa Rica in 2004 and the Imports(as % of merchandise exports) in Qatar in 2007?
Offer a terse response. 3.86. What is the difference between the Imports(as % of merchandise exports) in Hong Kong in 2004 and the Imports(as % of merchandise exports) in Namibia in 2007?
Your response must be concise. -12.16. What is the difference between the Imports(as % of merchandise exports) in Hong Kong in 2004 and the Imports(as % of merchandise exports) in Qatar in 2007?
Your answer should be very brief. -1.52. What is the difference between the Imports(as % of merchandise exports) of Namibia in 2004 and the Imports(as % of merchandise exports) of Qatar in 2007?
Your answer should be very brief. 13.83. What is the difference between the Imports(as % of merchandise exports) of Costa Rica in 2005 and the Imports(as % of merchandise exports) of Hong Kong in 2006?
Your answer should be compact. 3.48. What is the difference between the Imports(as % of merchandise exports) of Costa Rica in 2005 and the Imports(as % of merchandise exports) of Namibia in 2006?
Ensure brevity in your answer.  -9.91. What is the difference between the Imports(as % of merchandise exports) of Costa Rica in 2005 and the Imports(as % of merchandise exports) of Qatar in 2006?
Offer a very short reply. 1.13. What is the difference between the Imports(as % of merchandise exports) in Hong Kong in 2005 and the Imports(as % of merchandise exports) in Namibia in 2006?
Offer a terse response. -13.26. What is the difference between the Imports(as % of merchandise exports) of Hong Kong in 2005 and the Imports(as % of merchandise exports) of Qatar in 2006?
Keep it short and to the point. -2.23. What is the difference between the Imports(as % of merchandise exports) in Namibia in 2005 and the Imports(as % of merchandise exports) in Qatar in 2006?
Offer a very short reply. 12.73. What is the difference between the Imports(as % of merchandise exports) of Costa Rica in 2005 and the Imports(as % of merchandise exports) of Hong Kong in 2007?
Offer a very short reply. 3.26. What is the difference between the Imports(as % of merchandise exports) in Costa Rica in 2005 and the Imports(as % of merchandise exports) in Namibia in 2007?
Offer a terse response. -9.08. What is the difference between the Imports(as % of merchandise exports) of Costa Rica in 2005 and the Imports(as % of merchandise exports) of Qatar in 2007?
Keep it short and to the point. 1.56. What is the difference between the Imports(as % of merchandise exports) in Hong Kong in 2005 and the Imports(as % of merchandise exports) in Namibia in 2007?
Your answer should be compact. -12.44. What is the difference between the Imports(as % of merchandise exports) in Hong Kong in 2005 and the Imports(as % of merchandise exports) in Qatar in 2007?
Your answer should be very brief. -1.8. What is the difference between the Imports(as % of merchandise exports) of Namibia in 2005 and the Imports(as % of merchandise exports) of Qatar in 2007?
Keep it short and to the point. 13.16. What is the difference between the Imports(as % of merchandise exports) of Costa Rica in 2006 and the Imports(as % of merchandise exports) of Hong Kong in 2007?
Ensure brevity in your answer.  3.3. What is the difference between the Imports(as % of merchandise exports) in Costa Rica in 2006 and the Imports(as % of merchandise exports) in Namibia in 2007?
Your answer should be very brief. -9.04. What is the difference between the Imports(as % of merchandise exports) of Costa Rica in 2006 and the Imports(as % of merchandise exports) of Qatar in 2007?
Offer a terse response. 1.6. What is the difference between the Imports(as % of merchandise exports) in Hong Kong in 2006 and the Imports(as % of merchandise exports) in Namibia in 2007?
Your answer should be compact. -12.56. What is the difference between the Imports(as % of merchandise exports) of Hong Kong in 2006 and the Imports(as % of merchandise exports) of Qatar in 2007?
Offer a terse response. -1.92. What is the difference between the Imports(as % of merchandise exports) in Namibia in 2006 and the Imports(as % of merchandise exports) in Qatar in 2007?
Give a very brief answer. 11.46. What is the average Imports(as % of merchandise exports) in Costa Rica per year?
Your response must be concise. 7.51. What is the average Imports(as % of merchandise exports) of Hong Kong per year?
Offer a terse response. 3.55. What is the average Imports(as % of merchandise exports) of Namibia per year?
Offer a terse response. 15.67. What is the average Imports(as % of merchandise exports) in Qatar per year?
Your answer should be compact. 8.59. In the year 2000, what is the difference between the Imports(as % of merchandise exports) of Costa Rica and Imports(as % of merchandise exports) of Hong Kong?
Offer a terse response. 3.19. In the year 2000, what is the difference between the Imports(as % of merchandise exports) of Costa Rica and Imports(as % of merchandise exports) of Namibia?
Your answer should be compact. -9.37. In the year 2000, what is the difference between the Imports(as % of merchandise exports) in Costa Rica and Imports(as % of merchandise exports) in Qatar?
Your answer should be compact. -4.25. In the year 2000, what is the difference between the Imports(as % of merchandise exports) in Hong Kong and Imports(as % of merchandise exports) in Namibia?
Keep it short and to the point. -12.56. In the year 2000, what is the difference between the Imports(as % of merchandise exports) in Hong Kong and Imports(as % of merchandise exports) in Qatar?
Offer a very short reply. -7.44. In the year 2000, what is the difference between the Imports(as % of merchandise exports) in Namibia and Imports(as % of merchandise exports) in Qatar?
Your answer should be very brief. 5.12. In the year 2001, what is the difference between the Imports(as % of merchandise exports) of Costa Rica and Imports(as % of merchandise exports) of Hong Kong?
Make the answer very short. 3.19. In the year 2001, what is the difference between the Imports(as % of merchandise exports) of Costa Rica and Imports(as % of merchandise exports) of Namibia?
Provide a short and direct response. -5.59. In the year 2001, what is the difference between the Imports(as % of merchandise exports) of Costa Rica and Imports(as % of merchandise exports) of Qatar?
Offer a very short reply. -3.58. In the year 2001, what is the difference between the Imports(as % of merchandise exports) in Hong Kong and Imports(as % of merchandise exports) in Namibia?
Provide a short and direct response. -8.79. In the year 2001, what is the difference between the Imports(as % of merchandise exports) in Hong Kong and Imports(as % of merchandise exports) in Qatar?
Your response must be concise. -6.77. In the year 2001, what is the difference between the Imports(as % of merchandise exports) in Namibia and Imports(as % of merchandise exports) in Qatar?
Offer a very short reply. 2.01. In the year 2002, what is the difference between the Imports(as % of merchandise exports) of Costa Rica and Imports(as % of merchandise exports) of Hong Kong?
Provide a short and direct response. 3.92. In the year 2002, what is the difference between the Imports(as % of merchandise exports) in Costa Rica and Imports(as % of merchandise exports) in Namibia?
Provide a succinct answer. -4.44. In the year 2002, what is the difference between the Imports(as % of merchandise exports) in Costa Rica and Imports(as % of merchandise exports) in Qatar?
Keep it short and to the point. -3.9. In the year 2002, what is the difference between the Imports(as % of merchandise exports) of Hong Kong and Imports(as % of merchandise exports) of Namibia?
Your answer should be very brief. -8.36. In the year 2002, what is the difference between the Imports(as % of merchandise exports) of Hong Kong and Imports(as % of merchandise exports) of Qatar?
Your response must be concise. -7.82. In the year 2002, what is the difference between the Imports(as % of merchandise exports) in Namibia and Imports(as % of merchandise exports) in Qatar?
Your answer should be compact. 0.55. In the year 2003, what is the difference between the Imports(as % of merchandise exports) of Costa Rica and Imports(as % of merchandise exports) of Hong Kong?
Provide a short and direct response. 4.14. In the year 2003, what is the difference between the Imports(as % of merchandise exports) of Costa Rica and Imports(as % of merchandise exports) of Namibia?
Your answer should be very brief. -7.12. In the year 2003, what is the difference between the Imports(as % of merchandise exports) in Costa Rica and Imports(as % of merchandise exports) in Qatar?
Your answer should be compact. -2.15. In the year 2003, what is the difference between the Imports(as % of merchandise exports) in Hong Kong and Imports(as % of merchandise exports) in Namibia?
Your answer should be compact. -11.26. In the year 2003, what is the difference between the Imports(as % of merchandise exports) in Hong Kong and Imports(as % of merchandise exports) in Qatar?
Provide a succinct answer. -6.3. In the year 2003, what is the difference between the Imports(as % of merchandise exports) in Namibia and Imports(as % of merchandise exports) in Qatar?
Provide a succinct answer. 4.96. In the year 2004, what is the difference between the Imports(as % of merchandise exports) of Costa Rica and Imports(as % of merchandise exports) of Hong Kong?
Provide a succinct answer. 5.38. In the year 2004, what is the difference between the Imports(as % of merchandise exports) of Costa Rica and Imports(as % of merchandise exports) of Namibia?
Provide a short and direct response. -9.97. In the year 2004, what is the difference between the Imports(as % of merchandise exports) in Costa Rica and Imports(as % of merchandise exports) in Qatar?
Ensure brevity in your answer.  1.07. In the year 2004, what is the difference between the Imports(as % of merchandise exports) of Hong Kong and Imports(as % of merchandise exports) of Namibia?
Offer a terse response. -15.35. In the year 2004, what is the difference between the Imports(as % of merchandise exports) of Hong Kong and Imports(as % of merchandise exports) of Qatar?
Offer a terse response. -4.31. In the year 2004, what is the difference between the Imports(as % of merchandise exports) of Namibia and Imports(as % of merchandise exports) of Qatar?
Give a very brief answer. 11.04. In the year 2005, what is the difference between the Imports(as % of merchandise exports) of Costa Rica and Imports(as % of merchandise exports) of Hong Kong?
Your response must be concise. 3.36. In the year 2005, what is the difference between the Imports(as % of merchandise exports) of Costa Rica and Imports(as % of merchandise exports) of Namibia?
Offer a terse response. -11.6. In the year 2005, what is the difference between the Imports(as % of merchandise exports) of Costa Rica and Imports(as % of merchandise exports) of Qatar?
Your answer should be very brief. -0.27. In the year 2005, what is the difference between the Imports(as % of merchandise exports) in Hong Kong and Imports(as % of merchandise exports) in Namibia?
Provide a short and direct response. -14.96. In the year 2005, what is the difference between the Imports(as % of merchandise exports) of Hong Kong and Imports(as % of merchandise exports) of Qatar?
Provide a short and direct response. -3.63. In the year 2005, what is the difference between the Imports(as % of merchandise exports) in Namibia and Imports(as % of merchandise exports) in Qatar?
Your response must be concise. 11.33. In the year 2006, what is the difference between the Imports(as % of merchandise exports) of Costa Rica and Imports(as % of merchandise exports) of Hong Kong?
Provide a short and direct response. 3.52. In the year 2006, what is the difference between the Imports(as % of merchandise exports) in Costa Rica and Imports(as % of merchandise exports) in Namibia?
Keep it short and to the point. -9.87. In the year 2006, what is the difference between the Imports(as % of merchandise exports) in Costa Rica and Imports(as % of merchandise exports) in Qatar?
Provide a short and direct response. 1.17. In the year 2006, what is the difference between the Imports(as % of merchandise exports) in Hong Kong and Imports(as % of merchandise exports) in Namibia?
Offer a terse response. -13.38. In the year 2006, what is the difference between the Imports(as % of merchandise exports) in Hong Kong and Imports(as % of merchandise exports) in Qatar?
Give a very brief answer. -2.35. In the year 2006, what is the difference between the Imports(as % of merchandise exports) of Namibia and Imports(as % of merchandise exports) of Qatar?
Provide a succinct answer. 11.03. In the year 2007, what is the difference between the Imports(as % of merchandise exports) in Costa Rica and Imports(as % of merchandise exports) in Hong Kong?
Your response must be concise. 4.97. In the year 2007, what is the difference between the Imports(as % of merchandise exports) of Costa Rica and Imports(as % of merchandise exports) of Namibia?
Offer a very short reply. -7.38. In the year 2007, what is the difference between the Imports(as % of merchandise exports) of Costa Rica and Imports(as % of merchandise exports) of Qatar?
Provide a short and direct response. 3.26. In the year 2007, what is the difference between the Imports(as % of merchandise exports) in Hong Kong and Imports(as % of merchandise exports) in Namibia?
Give a very brief answer. -12.34. In the year 2007, what is the difference between the Imports(as % of merchandise exports) of Hong Kong and Imports(as % of merchandise exports) of Qatar?
Ensure brevity in your answer.  -1.7. In the year 2007, what is the difference between the Imports(as % of merchandise exports) in Namibia and Imports(as % of merchandise exports) in Qatar?
Keep it short and to the point. 10.64. What is the ratio of the Imports(as % of merchandise exports) in Hong Kong in 2000 to that in 2001?
Keep it short and to the point. 0.99. What is the ratio of the Imports(as % of merchandise exports) of Namibia in 2000 to that in 2001?
Your response must be concise. 1.28. What is the ratio of the Imports(as % of merchandise exports) in Qatar in 2000 to that in 2001?
Your response must be concise. 1.06. What is the ratio of the Imports(as % of merchandise exports) of Costa Rica in 2000 to that in 2002?
Provide a succinct answer. 0.93. What is the ratio of the Imports(as % of merchandise exports) of Hong Kong in 2000 to that in 2002?
Keep it short and to the point. 1.04. What is the ratio of the Imports(as % of merchandise exports) of Namibia in 2000 to that in 2002?
Offer a very short reply. 1.35. What is the ratio of the Imports(as % of merchandise exports) in Qatar in 2000 to that in 2002?
Offer a very short reply. 0.98. What is the ratio of the Imports(as % of merchandise exports) of Costa Rica in 2000 to that in 2003?
Your response must be concise. 0.96. What is the ratio of the Imports(as % of merchandise exports) of Hong Kong in 2000 to that in 2003?
Give a very brief answer. 1.18. What is the ratio of the Imports(as % of merchandise exports) in Namibia in 2000 to that in 2003?
Give a very brief answer. 1.13. What is the ratio of the Imports(as % of merchandise exports) of Qatar in 2000 to that in 2003?
Provide a succinct answer. 1.18. What is the ratio of the Imports(as % of merchandise exports) of Costa Rica in 2000 to that in 2004?
Keep it short and to the point. 0.87. What is the ratio of the Imports(as % of merchandise exports) in Hong Kong in 2000 to that in 2004?
Your answer should be very brief. 1.33. What is the ratio of the Imports(as % of merchandise exports) in Namibia in 2000 to that in 2004?
Give a very brief answer. 0.91. What is the ratio of the Imports(as % of merchandise exports) of Qatar in 2000 to that in 2004?
Your answer should be very brief. 1.56. What is the ratio of the Imports(as % of merchandise exports) of Costa Rica in 2000 to that in 2005?
Your answer should be very brief. 1.19. What is the ratio of the Imports(as % of merchandise exports) in Hong Kong in 2000 to that in 2005?
Your response must be concise. 1.45. What is the ratio of the Imports(as % of merchandise exports) in Namibia in 2000 to that in 2005?
Offer a terse response. 0.94. What is the ratio of the Imports(as % of merchandise exports) in Qatar in 2000 to that in 2005?
Ensure brevity in your answer.  1.78. What is the ratio of the Imports(as % of merchandise exports) in Costa Rica in 2000 to that in 2006?
Give a very brief answer. 1.18. What is the ratio of the Imports(as % of merchandise exports) of Hong Kong in 2000 to that in 2006?
Keep it short and to the point. 1.51. What is the ratio of the Imports(as % of merchandise exports) in Namibia in 2000 to that in 2006?
Offer a very short reply. 1.04. What is the ratio of the Imports(as % of merchandise exports) in Qatar in 2000 to that in 2006?
Give a very brief answer. 2.27. What is the ratio of the Imports(as % of merchandise exports) in Costa Rica in 2000 to that in 2007?
Offer a terse response. 0.93. What is the ratio of the Imports(as % of merchandise exports) of Hong Kong in 2000 to that in 2007?
Offer a very short reply. 1.41. What is the ratio of the Imports(as % of merchandise exports) in Namibia in 2000 to that in 2007?
Offer a terse response. 1.09. What is the ratio of the Imports(as % of merchandise exports) of Qatar in 2000 to that in 2007?
Keep it short and to the point. 2.47. What is the ratio of the Imports(as % of merchandise exports) in Costa Rica in 2001 to that in 2002?
Give a very brief answer. 0.94. What is the ratio of the Imports(as % of merchandise exports) of Hong Kong in 2001 to that in 2002?
Your response must be concise. 1.05. What is the ratio of the Imports(as % of merchandise exports) of Namibia in 2001 to that in 2002?
Give a very brief answer. 1.05. What is the ratio of the Imports(as % of merchandise exports) of Qatar in 2001 to that in 2002?
Make the answer very short. 0.93. What is the ratio of the Imports(as % of merchandise exports) in Costa Rica in 2001 to that in 2003?
Your answer should be very brief. 0.97. What is the ratio of the Imports(as % of merchandise exports) in Hong Kong in 2001 to that in 2003?
Keep it short and to the point. 1.2. What is the ratio of the Imports(as % of merchandise exports) in Namibia in 2001 to that in 2003?
Your answer should be compact. 0.88. What is the ratio of the Imports(as % of merchandise exports) of Qatar in 2001 to that in 2003?
Your response must be concise. 1.12. What is the ratio of the Imports(as % of merchandise exports) of Costa Rica in 2001 to that in 2004?
Your answer should be very brief. 0.87. What is the ratio of the Imports(as % of merchandise exports) in Hong Kong in 2001 to that in 2004?
Your answer should be very brief. 1.35. What is the ratio of the Imports(as % of merchandise exports) of Namibia in 2001 to that in 2004?
Offer a very short reply. 0.71. What is the ratio of the Imports(as % of merchandise exports) in Qatar in 2001 to that in 2004?
Your answer should be very brief. 1.47. What is the ratio of the Imports(as % of merchandise exports) of Costa Rica in 2001 to that in 2005?
Provide a short and direct response. 1.19. What is the ratio of the Imports(as % of merchandise exports) of Hong Kong in 2001 to that in 2005?
Give a very brief answer. 1.47. What is the ratio of the Imports(as % of merchandise exports) of Namibia in 2001 to that in 2005?
Give a very brief answer. 0.73. What is the ratio of the Imports(as % of merchandise exports) of Qatar in 2001 to that in 2005?
Offer a terse response. 1.69. What is the ratio of the Imports(as % of merchandise exports) in Costa Rica in 2001 to that in 2006?
Your answer should be compact. 1.19. What is the ratio of the Imports(as % of merchandise exports) of Hong Kong in 2001 to that in 2006?
Offer a terse response. 1.53. What is the ratio of the Imports(as % of merchandise exports) of Namibia in 2001 to that in 2006?
Keep it short and to the point. 0.81. What is the ratio of the Imports(as % of merchandise exports) of Qatar in 2001 to that in 2006?
Your answer should be compact. 2.15. What is the ratio of the Imports(as % of merchandise exports) in Costa Rica in 2001 to that in 2007?
Give a very brief answer. 0.94. What is the ratio of the Imports(as % of merchandise exports) of Hong Kong in 2001 to that in 2007?
Provide a succinct answer. 1.43. What is the ratio of the Imports(as % of merchandise exports) of Namibia in 2001 to that in 2007?
Give a very brief answer. 0.85. What is the ratio of the Imports(as % of merchandise exports) of Qatar in 2001 to that in 2007?
Provide a short and direct response. 2.34. What is the ratio of the Imports(as % of merchandise exports) of Costa Rica in 2002 to that in 2003?
Offer a very short reply. 1.04. What is the ratio of the Imports(as % of merchandise exports) of Hong Kong in 2002 to that in 2003?
Your answer should be compact. 1.14. What is the ratio of the Imports(as % of merchandise exports) in Namibia in 2002 to that in 2003?
Your response must be concise. 0.84. What is the ratio of the Imports(as % of merchandise exports) in Qatar in 2002 to that in 2003?
Your answer should be compact. 1.2. What is the ratio of the Imports(as % of merchandise exports) of Costa Rica in 2002 to that in 2004?
Offer a very short reply. 0.93. What is the ratio of the Imports(as % of merchandise exports) in Hong Kong in 2002 to that in 2004?
Your response must be concise. 1.28. What is the ratio of the Imports(as % of merchandise exports) in Namibia in 2002 to that in 2004?
Keep it short and to the point. 0.67. What is the ratio of the Imports(as % of merchandise exports) of Qatar in 2002 to that in 2004?
Keep it short and to the point. 1.58. What is the ratio of the Imports(as % of merchandise exports) of Costa Rica in 2002 to that in 2005?
Your answer should be very brief. 1.28. What is the ratio of the Imports(as % of merchandise exports) of Hong Kong in 2002 to that in 2005?
Give a very brief answer. 1.4. What is the ratio of the Imports(as % of merchandise exports) of Namibia in 2002 to that in 2005?
Your answer should be compact. 0.7. What is the ratio of the Imports(as % of merchandise exports) in Qatar in 2002 to that in 2005?
Your response must be concise. 1.82. What is the ratio of the Imports(as % of merchandise exports) in Costa Rica in 2002 to that in 2006?
Provide a succinct answer. 1.27. What is the ratio of the Imports(as % of merchandise exports) of Hong Kong in 2002 to that in 2006?
Keep it short and to the point. 1.46. What is the ratio of the Imports(as % of merchandise exports) in Namibia in 2002 to that in 2006?
Your response must be concise. 0.77. What is the ratio of the Imports(as % of merchandise exports) of Qatar in 2002 to that in 2006?
Your response must be concise. 2.31. What is the ratio of the Imports(as % of merchandise exports) of Costa Rica in 2002 to that in 2007?
Your answer should be very brief. 1. What is the ratio of the Imports(as % of merchandise exports) of Hong Kong in 2002 to that in 2007?
Keep it short and to the point. 1.36. What is the ratio of the Imports(as % of merchandise exports) of Namibia in 2002 to that in 2007?
Your answer should be very brief. 0.81. What is the ratio of the Imports(as % of merchandise exports) of Qatar in 2002 to that in 2007?
Your answer should be compact. 2.52. What is the ratio of the Imports(as % of merchandise exports) of Costa Rica in 2003 to that in 2004?
Your response must be concise. 0.9. What is the ratio of the Imports(as % of merchandise exports) in Hong Kong in 2003 to that in 2004?
Ensure brevity in your answer.  1.12. What is the ratio of the Imports(as % of merchandise exports) of Namibia in 2003 to that in 2004?
Make the answer very short. 0.8. What is the ratio of the Imports(as % of merchandise exports) in Qatar in 2003 to that in 2004?
Provide a short and direct response. 1.32. What is the ratio of the Imports(as % of merchandise exports) in Costa Rica in 2003 to that in 2005?
Ensure brevity in your answer.  1.23. What is the ratio of the Imports(as % of merchandise exports) in Hong Kong in 2003 to that in 2005?
Make the answer very short. 1.23. What is the ratio of the Imports(as % of merchandise exports) of Namibia in 2003 to that in 2005?
Your response must be concise. 0.83. What is the ratio of the Imports(as % of merchandise exports) of Qatar in 2003 to that in 2005?
Your answer should be very brief. 1.51. What is the ratio of the Imports(as % of merchandise exports) in Costa Rica in 2003 to that in 2006?
Provide a succinct answer. 1.22. What is the ratio of the Imports(as % of merchandise exports) in Hong Kong in 2003 to that in 2006?
Offer a very short reply. 1.28. What is the ratio of the Imports(as % of merchandise exports) of Namibia in 2003 to that in 2006?
Your response must be concise. 0.92. What is the ratio of the Imports(as % of merchandise exports) in Qatar in 2003 to that in 2006?
Give a very brief answer. 1.92. What is the ratio of the Imports(as % of merchandise exports) in Costa Rica in 2003 to that in 2007?
Give a very brief answer. 0.97. What is the ratio of the Imports(as % of merchandise exports) of Hong Kong in 2003 to that in 2007?
Ensure brevity in your answer.  1.19. What is the ratio of the Imports(as % of merchandise exports) of Namibia in 2003 to that in 2007?
Make the answer very short. 0.97. What is the ratio of the Imports(as % of merchandise exports) of Qatar in 2003 to that in 2007?
Provide a short and direct response. 2.09. What is the ratio of the Imports(as % of merchandise exports) in Costa Rica in 2004 to that in 2005?
Ensure brevity in your answer.  1.37. What is the ratio of the Imports(as % of merchandise exports) in Hong Kong in 2004 to that in 2005?
Ensure brevity in your answer.  1.1. What is the ratio of the Imports(as % of merchandise exports) in Namibia in 2004 to that in 2005?
Offer a terse response. 1.04. What is the ratio of the Imports(as % of merchandise exports) in Qatar in 2004 to that in 2005?
Offer a very short reply. 1.15. What is the ratio of the Imports(as % of merchandise exports) in Costa Rica in 2004 to that in 2006?
Offer a terse response. 1.36. What is the ratio of the Imports(as % of merchandise exports) of Hong Kong in 2004 to that in 2006?
Offer a terse response. 1.14. What is the ratio of the Imports(as % of merchandise exports) in Namibia in 2004 to that in 2006?
Provide a short and direct response. 1.15. What is the ratio of the Imports(as % of merchandise exports) of Qatar in 2004 to that in 2006?
Make the answer very short. 1.46. What is the ratio of the Imports(as % of merchandise exports) in Costa Rica in 2004 to that in 2007?
Your response must be concise. 1.07. What is the ratio of the Imports(as % of merchandise exports) of Hong Kong in 2004 to that in 2007?
Offer a very short reply. 1.06. What is the ratio of the Imports(as % of merchandise exports) in Namibia in 2004 to that in 2007?
Give a very brief answer. 1.21. What is the ratio of the Imports(as % of merchandise exports) of Qatar in 2004 to that in 2007?
Provide a succinct answer. 1.59. What is the ratio of the Imports(as % of merchandise exports) of Costa Rica in 2005 to that in 2006?
Offer a terse response. 0.99. What is the ratio of the Imports(as % of merchandise exports) of Hong Kong in 2005 to that in 2006?
Give a very brief answer. 1.04. What is the ratio of the Imports(as % of merchandise exports) of Namibia in 2005 to that in 2006?
Provide a short and direct response. 1.1. What is the ratio of the Imports(as % of merchandise exports) of Qatar in 2005 to that in 2006?
Offer a very short reply. 1.27. What is the ratio of the Imports(as % of merchandise exports) in Costa Rica in 2005 to that in 2007?
Make the answer very short. 0.79. What is the ratio of the Imports(as % of merchandise exports) of Hong Kong in 2005 to that in 2007?
Keep it short and to the point. 0.97. What is the ratio of the Imports(as % of merchandise exports) in Namibia in 2005 to that in 2007?
Offer a terse response. 1.16. What is the ratio of the Imports(as % of merchandise exports) in Qatar in 2005 to that in 2007?
Your answer should be compact. 1.39. What is the ratio of the Imports(as % of merchandise exports) of Costa Rica in 2006 to that in 2007?
Offer a very short reply. 0.79. What is the ratio of the Imports(as % of merchandise exports) of Hong Kong in 2006 to that in 2007?
Provide a short and direct response. 0.93. What is the ratio of the Imports(as % of merchandise exports) of Namibia in 2006 to that in 2007?
Your answer should be compact. 1.05. What is the difference between the highest and the second highest Imports(as % of merchandise exports) in Costa Rica?
Offer a terse response. 0.57. What is the difference between the highest and the second highest Imports(as % of merchandise exports) in Hong Kong?
Offer a very short reply. 0.06. What is the difference between the highest and the second highest Imports(as % of merchandise exports) in Namibia?
Keep it short and to the point. 0.67. What is the difference between the highest and the second highest Imports(as % of merchandise exports) of Qatar?
Give a very brief answer. 0.21. What is the difference between the highest and the lowest Imports(as % of merchandise exports) of Costa Rica?
Make the answer very short. 2.31. What is the difference between the highest and the lowest Imports(as % of merchandise exports) in Hong Kong?
Your answer should be very brief. 1.51. What is the difference between the highest and the lowest Imports(as % of merchandise exports) in Namibia?
Offer a very short reply. 6.09. What is the difference between the highest and the lowest Imports(as % of merchandise exports) of Qatar?
Your response must be concise. 7.19. 